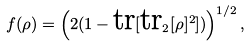Convert formula to latex. <formula><loc_0><loc_0><loc_500><loc_500>f ( \rho ) = \left ( 2 ( 1 - \text {tr} [ \text {tr} _ { 2 } [ \rho ] ^ { 2 } ] ) \right ) ^ { 1 / 2 } ,</formula> 